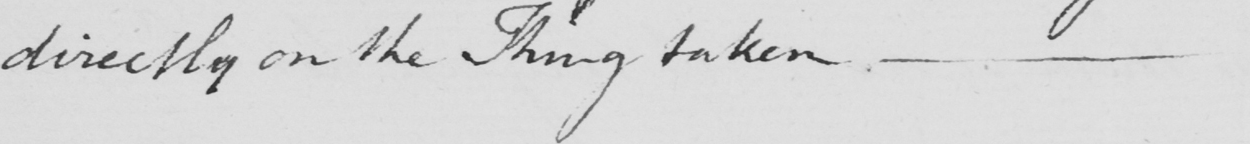Please transcribe the handwritten text in this image. directly on the Thing taken , 